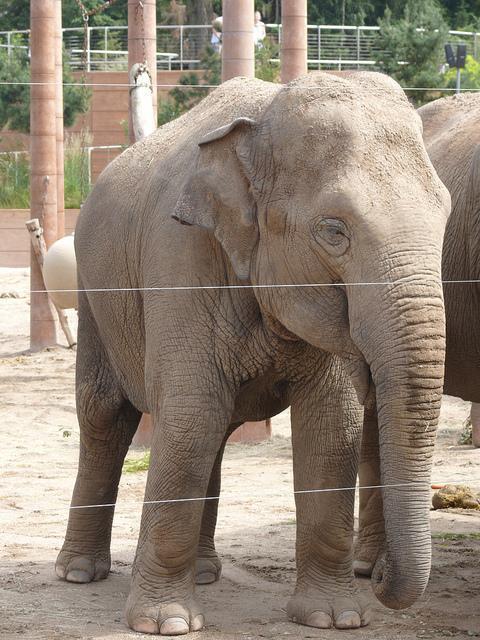How many legs does this animal have?
Give a very brief answer. 4. How many elephants are in the photo?
Give a very brief answer. 2. 